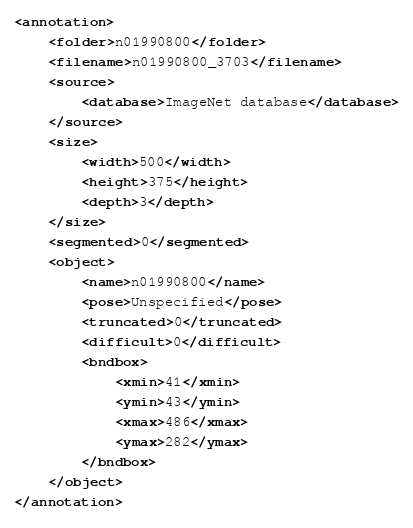Convert code to text. <code><loc_0><loc_0><loc_500><loc_500><_XML_><annotation>
	<folder>n01990800</folder>
	<filename>n01990800_3703</filename>
	<source>
		<database>ImageNet database</database>
	</source>
	<size>
		<width>500</width>
		<height>375</height>
		<depth>3</depth>
	</size>
	<segmented>0</segmented>
	<object>
		<name>n01990800</name>
		<pose>Unspecified</pose>
		<truncated>0</truncated>
		<difficult>0</difficult>
		<bndbox>
			<xmin>41</xmin>
			<ymin>43</ymin>
			<xmax>486</xmax>
			<ymax>282</ymax>
		</bndbox>
	</object>
</annotation></code> 